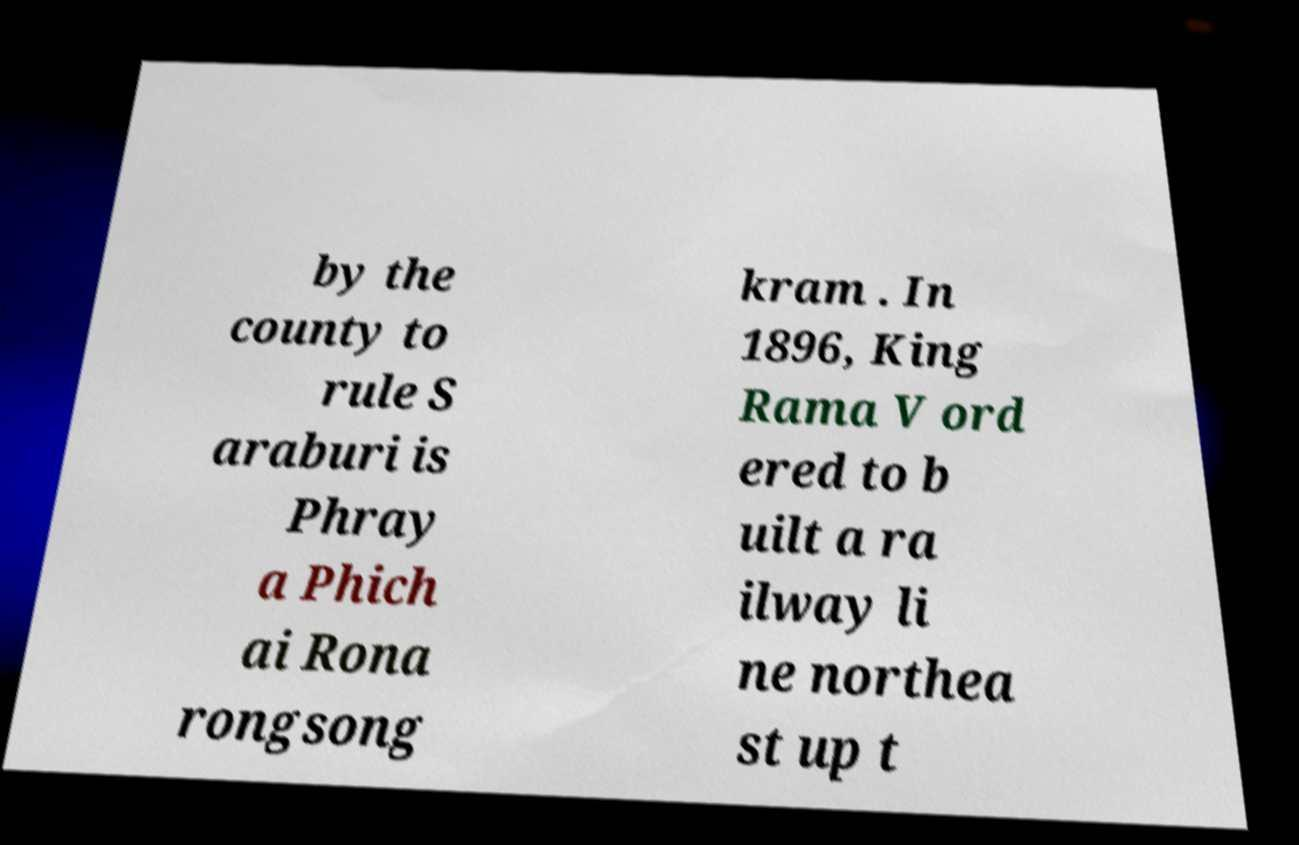Could you extract and type out the text from this image? by the county to rule S araburi is Phray a Phich ai Rona rongsong kram . In 1896, King Rama V ord ered to b uilt a ra ilway li ne northea st up t 